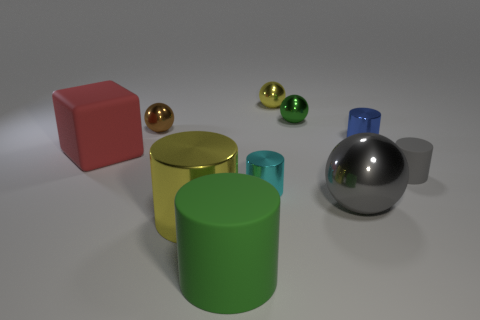Subtract all gray cylinders. How many cylinders are left? 4 Subtract all large metallic cylinders. How many cylinders are left? 4 Subtract 1 cylinders. How many cylinders are left? 4 Subtract all red cylinders. Subtract all red balls. How many cylinders are left? 5 Subtract all blocks. How many objects are left? 9 Add 4 big things. How many big things are left? 8 Add 2 yellow matte objects. How many yellow matte objects exist? 2 Subtract 0 purple cylinders. How many objects are left? 10 Subtract all small brown metallic cubes. Subtract all tiny cyan cylinders. How many objects are left? 9 